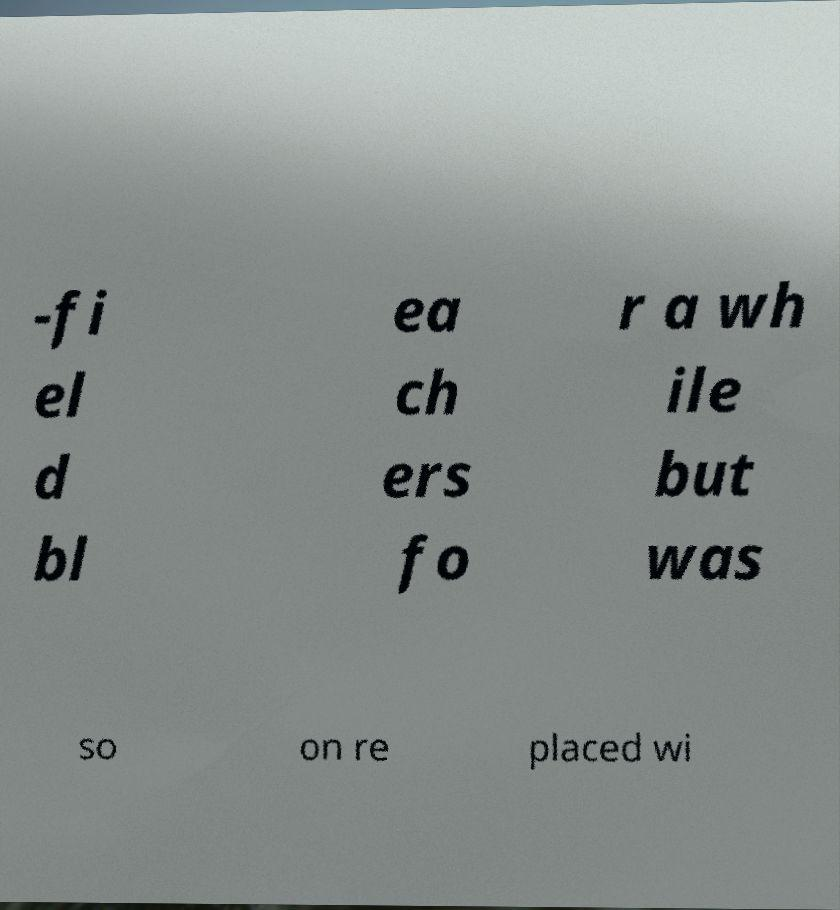Please read and relay the text visible in this image. What does it say? -fi el d bl ea ch ers fo r a wh ile but was so on re placed wi 